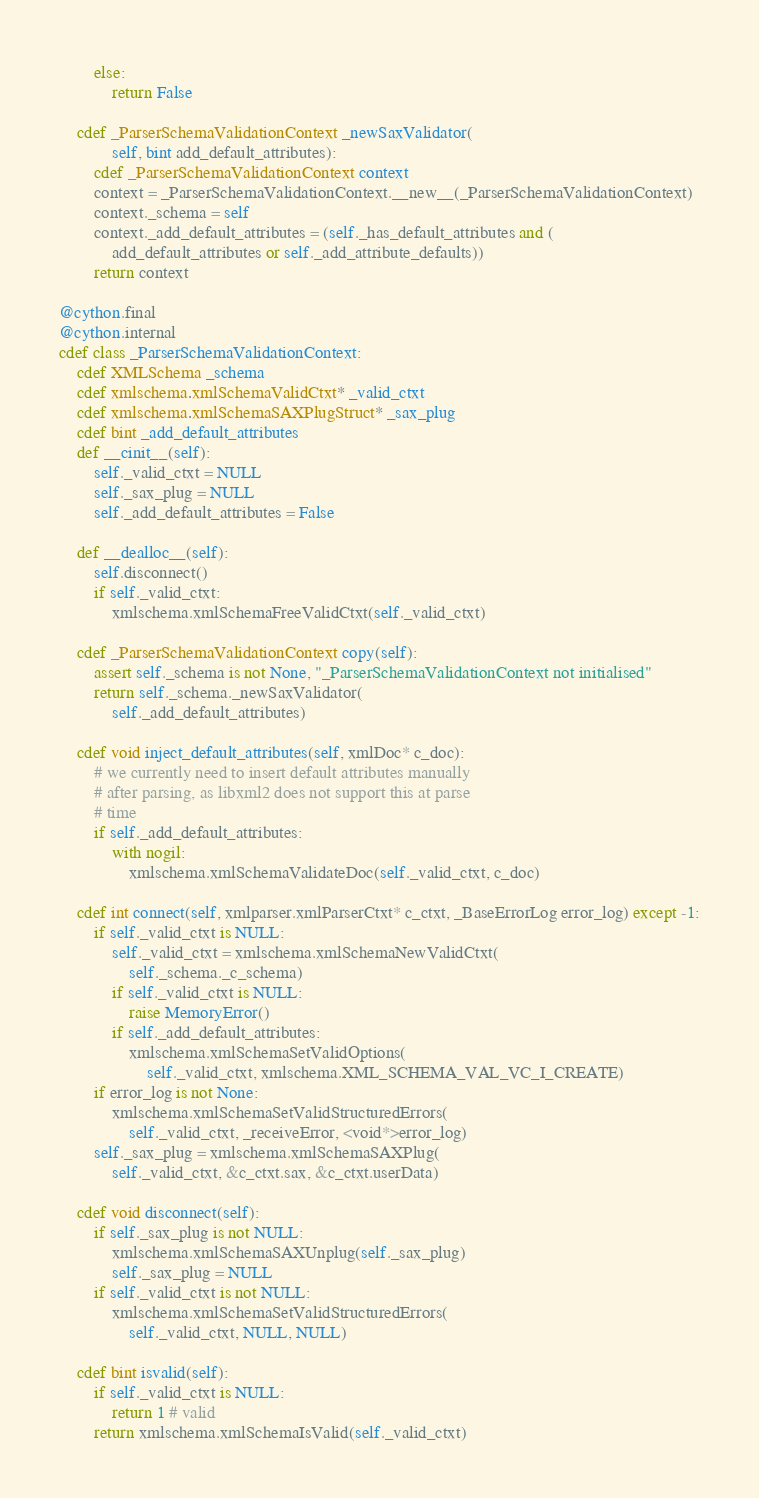<code> <loc_0><loc_0><loc_500><loc_500><_Cython_>        else:
            return False

    cdef _ParserSchemaValidationContext _newSaxValidator(
            self, bint add_default_attributes):
        cdef _ParserSchemaValidationContext context
        context = _ParserSchemaValidationContext.__new__(_ParserSchemaValidationContext)
        context._schema = self
        context._add_default_attributes = (self._has_default_attributes and (
            add_default_attributes or self._add_attribute_defaults))
        return context

@cython.final
@cython.internal
cdef class _ParserSchemaValidationContext:
    cdef XMLSchema _schema
    cdef xmlschema.xmlSchemaValidCtxt* _valid_ctxt
    cdef xmlschema.xmlSchemaSAXPlugStruct* _sax_plug
    cdef bint _add_default_attributes
    def __cinit__(self):
        self._valid_ctxt = NULL
        self._sax_plug = NULL
        self._add_default_attributes = False

    def __dealloc__(self):
        self.disconnect()
        if self._valid_ctxt:
            xmlschema.xmlSchemaFreeValidCtxt(self._valid_ctxt)

    cdef _ParserSchemaValidationContext copy(self):
        assert self._schema is not None, "_ParserSchemaValidationContext not initialised"
        return self._schema._newSaxValidator(
            self._add_default_attributes)

    cdef void inject_default_attributes(self, xmlDoc* c_doc):
        # we currently need to insert default attributes manually
        # after parsing, as libxml2 does not support this at parse
        # time
        if self._add_default_attributes:
            with nogil:
                xmlschema.xmlSchemaValidateDoc(self._valid_ctxt, c_doc)

    cdef int connect(self, xmlparser.xmlParserCtxt* c_ctxt, _BaseErrorLog error_log) except -1:
        if self._valid_ctxt is NULL:
            self._valid_ctxt = xmlschema.xmlSchemaNewValidCtxt(
                self._schema._c_schema)
            if self._valid_ctxt is NULL:
                raise MemoryError()
            if self._add_default_attributes:
                xmlschema.xmlSchemaSetValidOptions(
                    self._valid_ctxt, xmlschema.XML_SCHEMA_VAL_VC_I_CREATE)
        if error_log is not None:
            xmlschema.xmlSchemaSetValidStructuredErrors(
                self._valid_ctxt, _receiveError, <void*>error_log)
        self._sax_plug = xmlschema.xmlSchemaSAXPlug(
            self._valid_ctxt, &c_ctxt.sax, &c_ctxt.userData)

    cdef void disconnect(self):
        if self._sax_plug is not NULL:
            xmlschema.xmlSchemaSAXUnplug(self._sax_plug)
            self._sax_plug = NULL
        if self._valid_ctxt is not NULL:
            xmlschema.xmlSchemaSetValidStructuredErrors(
                self._valid_ctxt, NULL, NULL)

    cdef bint isvalid(self):
        if self._valid_ctxt is NULL:
            return 1 # valid
        return xmlschema.xmlSchemaIsValid(self._valid_ctxt)
</code> 